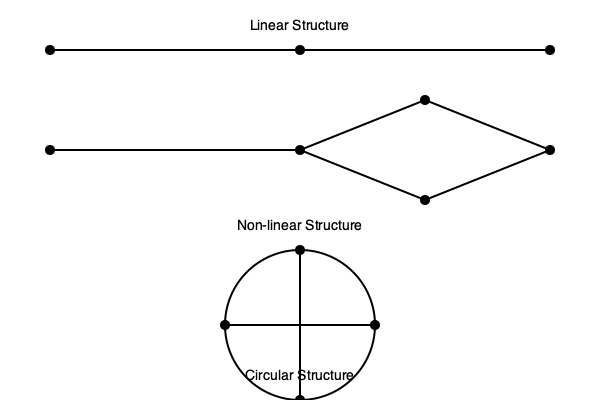As a news editor collaborating with a filmmaker on thought-provoking documentaries, analyze the three narrative structures depicted in the flowchart. Which structure would be most effective for a documentary exploring the cyclical nature of historical events, and why? To answer this question, let's examine each narrative structure and its potential application to a documentary about the cyclical nature of historical events:

1. Linear Structure:
   - Represented by a straight line with a clear beginning, middle, and end.
   - Pros: Simple to follow, chronological, good for cause-and-effect storytelling.
   - Cons: May not effectively capture the cyclical nature of historical events.

2. Non-linear Structure:
   - Represented by a branching pattern with multiple paths and connections.
   - Pros: Allows for exploration of multiple perspectives and interconnected events.
   - Cons: Can be complex and potentially confusing for viewers, may not clearly show repetitive patterns.

3. Circular Structure:
   - Represented by a circle with interconnected points.
   - Pros: 
     a) Visually represents the cyclical nature of events.
     b) Allows for seamless transitions between different time periods.
     c) Emphasizes patterns and repetitions in history.
     d) Can start and end at any point, reinforcing the idea of continuous cycles.
   - Cons: May be challenging to maintain a clear narrative progression.

For a documentary exploring the cyclical nature of historical events, the circular structure would be most effective because:

1. It visually reinforces the concept of cycles in history.
2. It allows for easy comparison of similar events across different time periods.
3. It emphasizes patterns and repetitions, which is crucial for understanding cyclical historical trends.
4. It provides flexibility in storytelling, allowing the filmmaker to draw connections between non-adjacent events.
5. It can create a powerful closing that links back to the opening, leaving a lasting impression on viewers about the repetitive nature of history.

While the non-linear structure could also be used to show connections between events, the circular structure more explicitly represents the cyclical concept, making it the most effective choice for this particular documentary topic.
Answer: Circular Structure 